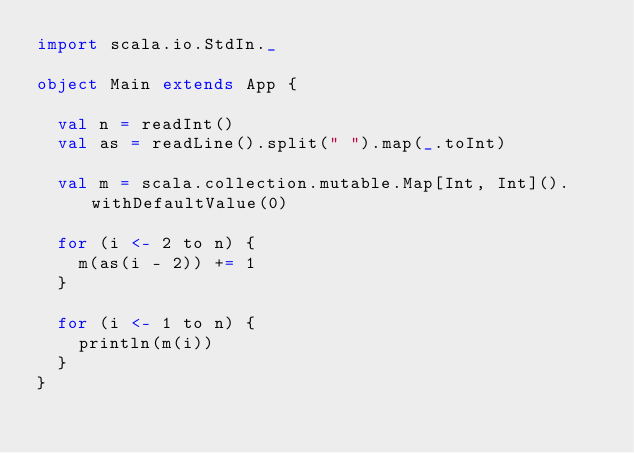Convert code to text. <code><loc_0><loc_0><loc_500><loc_500><_Scala_>import scala.io.StdIn._

object Main extends App {

  val n = readInt()
  val as = readLine().split(" ").map(_.toInt)

  val m = scala.collection.mutable.Map[Int, Int]().withDefaultValue(0)
  
  for (i <- 2 to n) {
    m(as(i - 2)) += 1
  }

  for (i <- 1 to n) {
    println(m(i))
  }
}
</code> 